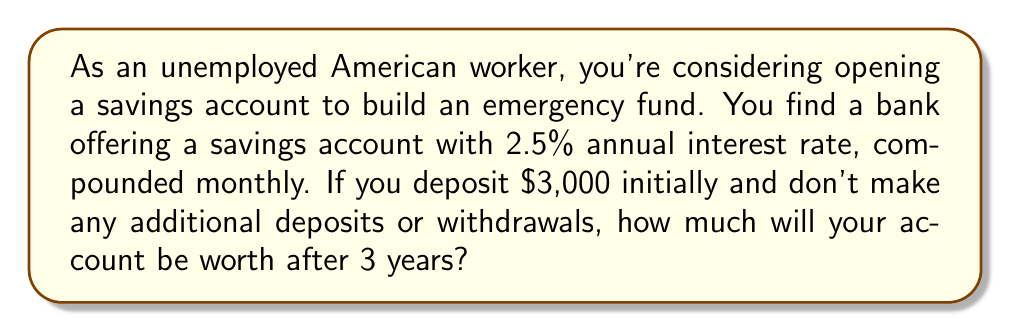Could you help me with this problem? To solve this problem, we'll use the compound interest formula:

$$A = P(1 + \frac{r}{n})^{nt}$$

Where:
$A$ = final amount
$P$ = principal (initial deposit)
$r$ = annual interest rate (in decimal form)
$n$ = number of times interest is compounded per year
$t$ = number of years

Given information:
$P = $3,000$
$r = 2.5\% = 0.025$
$n = 12$ (compounded monthly)
$t = 3$ years

Let's plug these values into the formula:

$$A = 3000(1 + \frac{0.025}{12})^{12 \cdot 3}$$

$$A = 3000(1 + 0.002083333...)^{36}$$

$$A = 3000(1.002083333...)^{36}$$

$$A = 3000 \cdot 1.077815533...$$

$$A = 3233.45$$

Rounding to the nearest cent, we get $3,233.45.
Answer: $3,233.45 